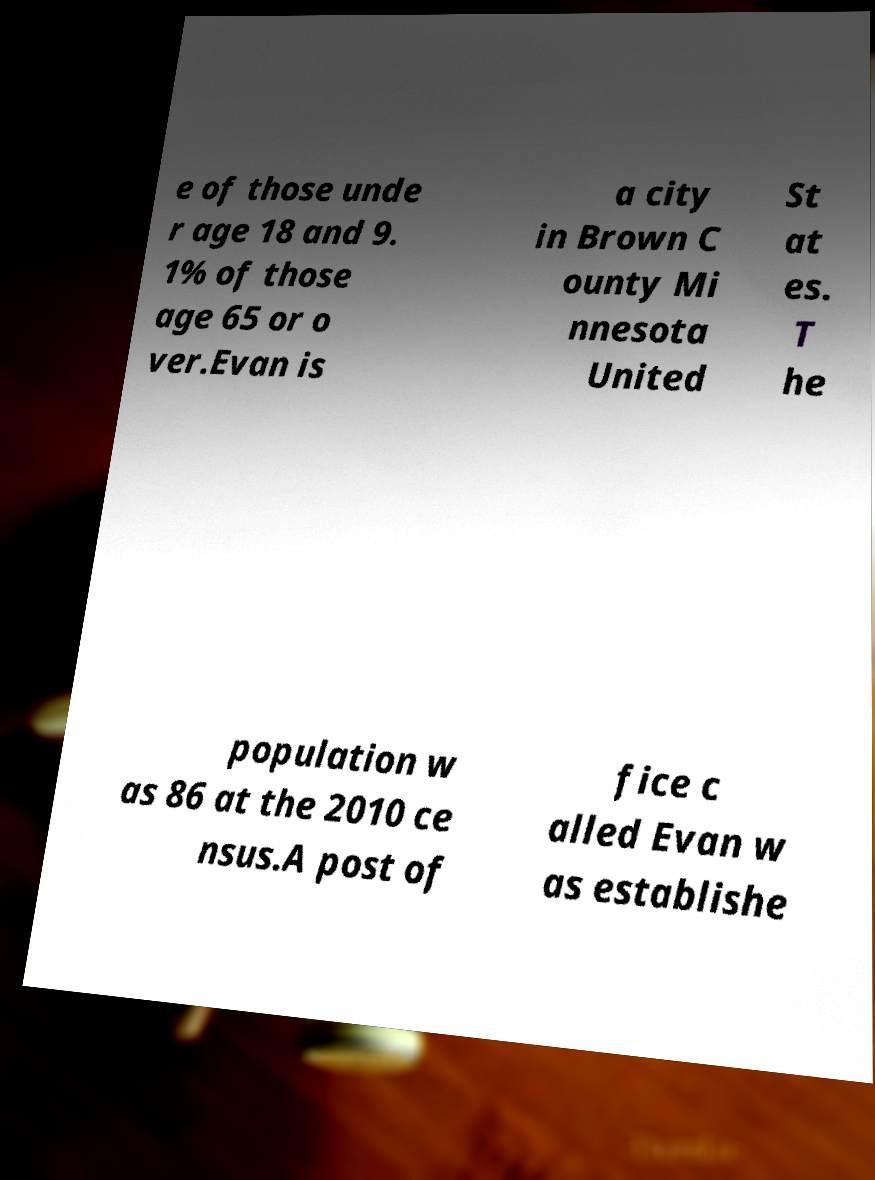There's text embedded in this image that I need extracted. Can you transcribe it verbatim? e of those unde r age 18 and 9. 1% of those age 65 or o ver.Evan is a city in Brown C ounty Mi nnesota United St at es. T he population w as 86 at the 2010 ce nsus.A post of fice c alled Evan w as establishe 